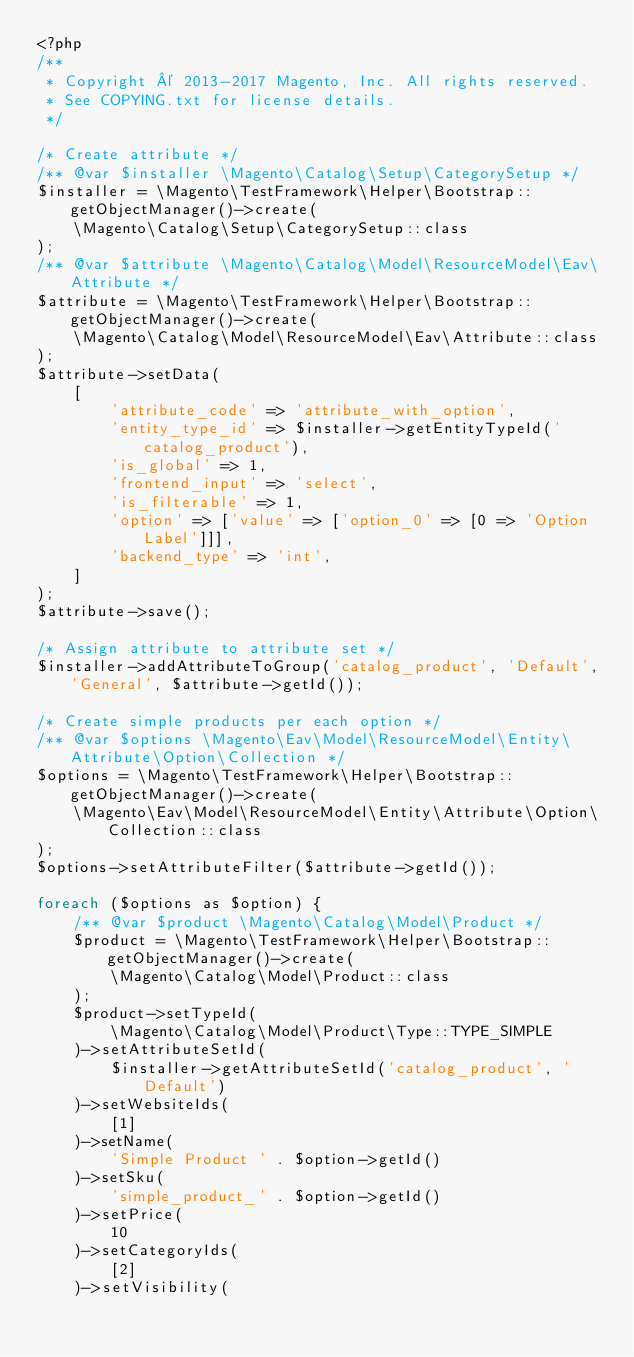<code> <loc_0><loc_0><loc_500><loc_500><_PHP_><?php
/**
 * Copyright © 2013-2017 Magento, Inc. All rights reserved.
 * See COPYING.txt for license details.
 */

/* Create attribute */
/** @var $installer \Magento\Catalog\Setup\CategorySetup */
$installer = \Magento\TestFramework\Helper\Bootstrap::getObjectManager()->create(
    \Magento\Catalog\Setup\CategorySetup::class
);
/** @var $attribute \Magento\Catalog\Model\ResourceModel\Eav\Attribute */
$attribute = \Magento\TestFramework\Helper\Bootstrap::getObjectManager()->create(
    \Magento\Catalog\Model\ResourceModel\Eav\Attribute::class
);
$attribute->setData(
    [
        'attribute_code' => 'attribute_with_option',
        'entity_type_id' => $installer->getEntityTypeId('catalog_product'),
        'is_global' => 1,
        'frontend_input' => 'select',
        'is_filterable' => 1,
        'option' => ['value' => ['option_0' => [0 => 'Option Label']]],
        'backend_type' => 'int',
    ]
);
$attribute->save();

/* Assign attribute to attribute set */
$installer->addAttributeToGroup('catalog_product', 'Default', 'General', $attribute->getId());

/* Create simple products per each option */
/** @var $options \Magento\Eav\Model\ResourceModel\Entity\Attribute\Option\Collection */
$options = \Magento\TestFramework\Helper\Bootstrap::getObjectManager()->create(
    \Magento\Eav\Model\ResourceModel\Entity\Attribute\Option\Collection::class
);
$options->setAttributeFilter($attribute->getId());

foreach ($options as $option) {
    /** @var $product \Magento\Catalog\Model\Product */
    $product = \Magento\TestFramework\Helper\Bootstrap::getObjectManager()->create(
        \Magento\Catalog\Model\Product::class
    );
    $product->setTypeId(
        \Magento\Catalog\Model\Product\Type::TYPE_SIMPLE
    )->setAttributeSetId(
        $installer->getAttributeSetId('catalog_product', 'Default')
    )->setWebsiteIds(
        [1]
    )->setName(
        'Simple Product ' . $option->getId()
    )->setSku(
        'simple_product_' . $option->getId()
    )->setPrice(
        10
    )->setCategoryIds(
        [2]
    )->setVisibility(</code> 